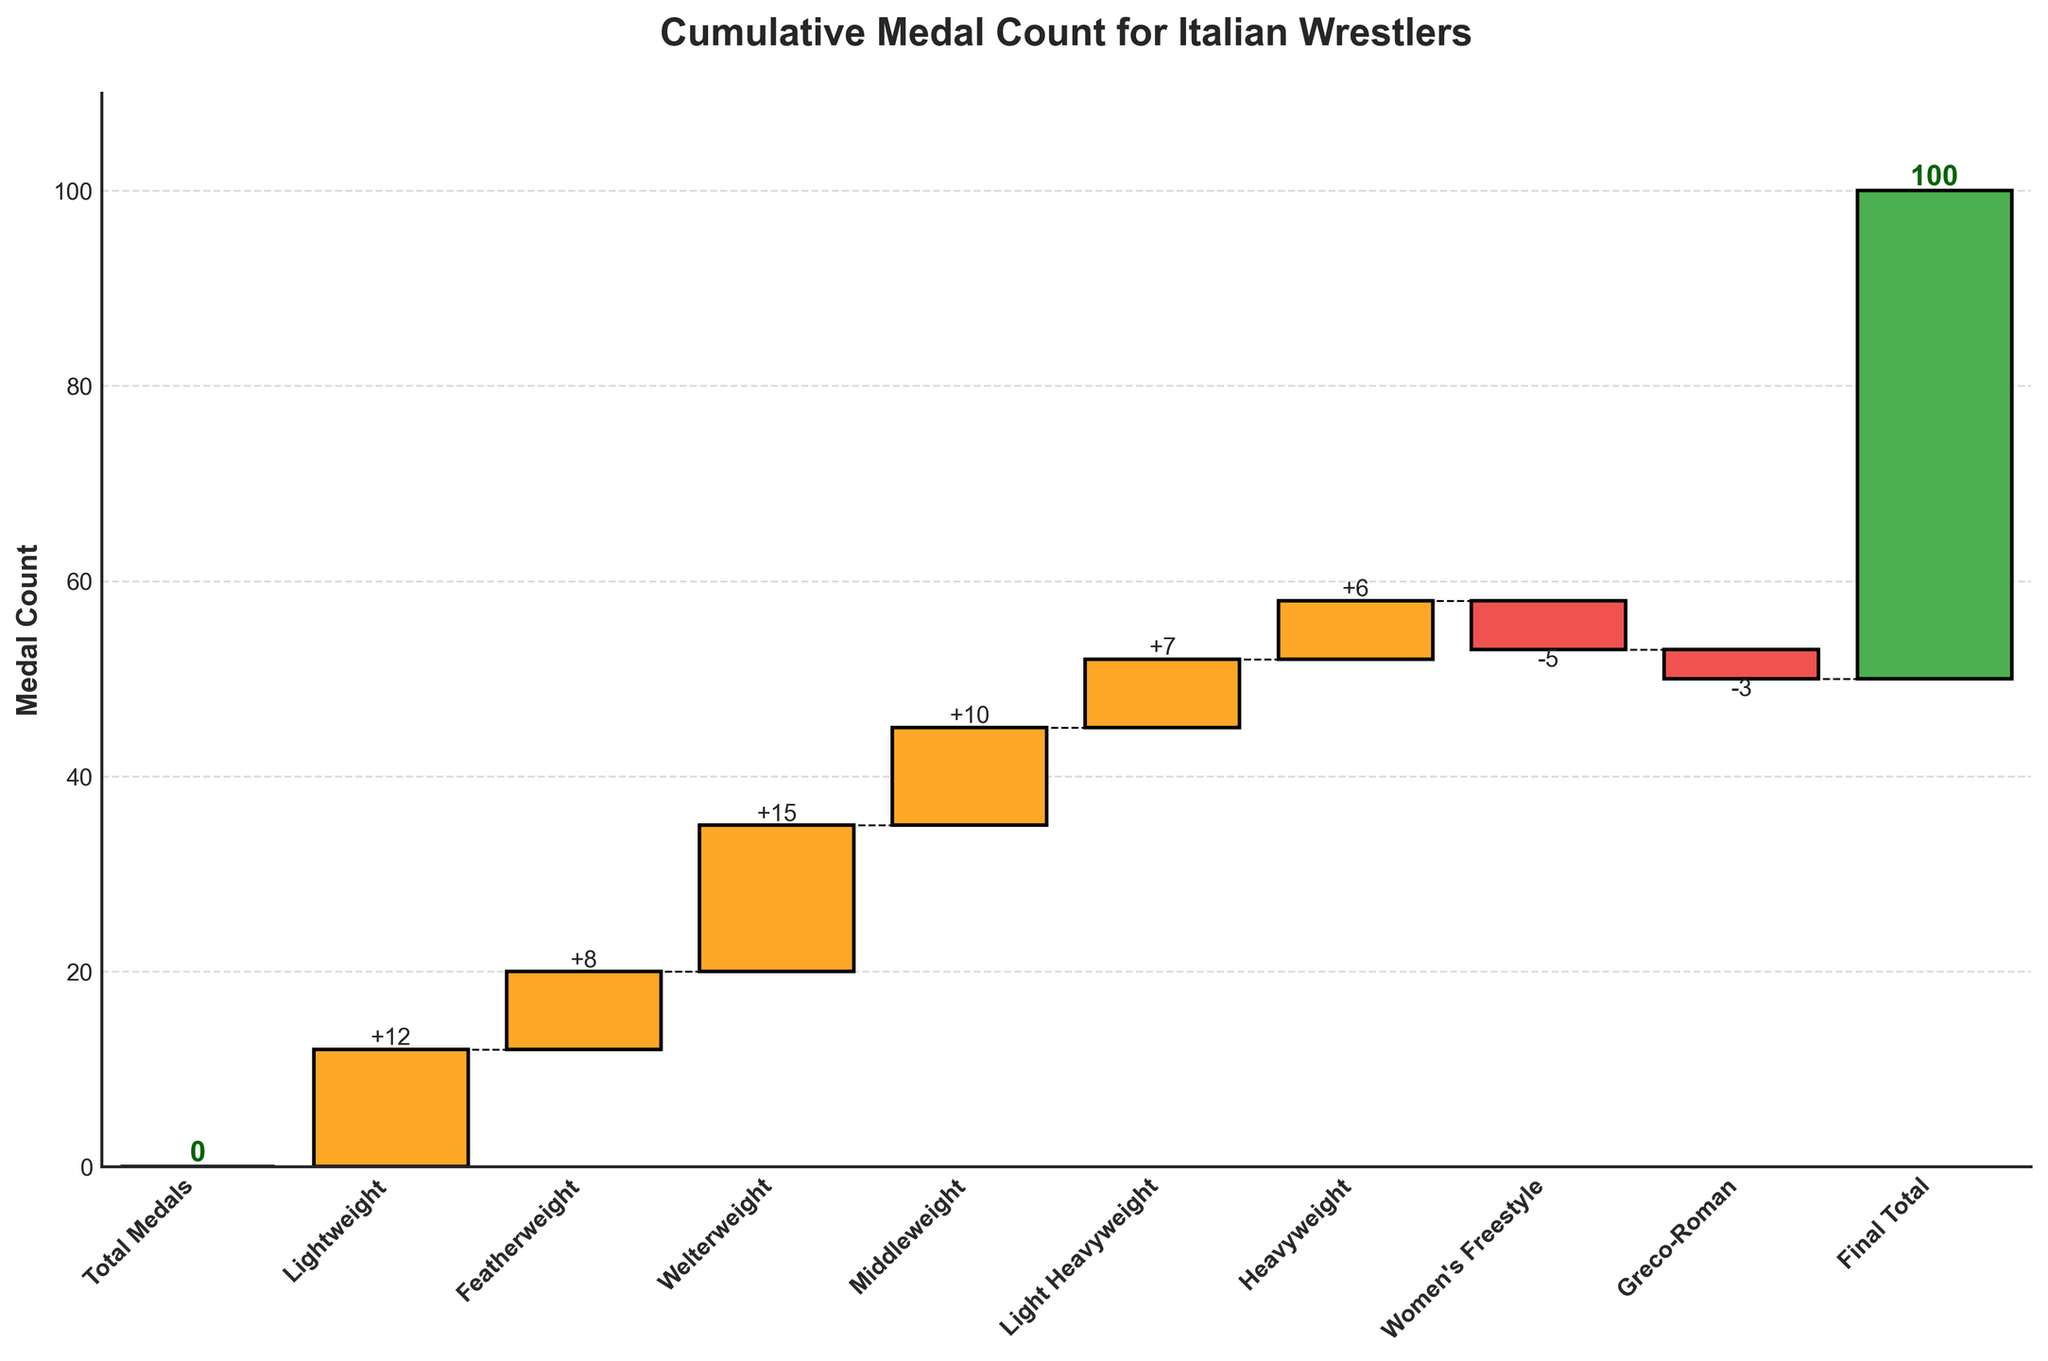What's the title of the chart? The title of the chart is usually displayed prominently at the top. In this case, it reads "Cumulative Medal Count for Italian Wrestlers".
Answer: Cumulative Medal Count for Italian Wrestlers What is the value for the Welterweight category? Locate the Welterweight bar on the x-axis and read the value associated with it. The Welterweight bar has a positive value of 15 medals.
Answer: 15 What is the effect of the Women's Freestyle category on the cumulative medal count? Identify the Women's Freestyle category. The bar is negative, meaning it reduces the cumulative medal count by 5 medals.
Answer: -5 Which weight class has the highest contribution to the total medal count? Compare all positive bars to find the highest one. The Welterweight category has the highest value of 15 medals.
Answer: Welterweight By how much does the Greco-Roman category reduce the cumulative total? Locate the Greco-Roman category bar which is negative and read its value. It reduces the total by 3 medals.
Answer: 3 How many weight classes have a positive contribution to the medal count? Count all bars with positive values. They are Lightweight, Featherweight, Welterweight, Middleweight, Light Heavyweight, and Heavyweight, totaling 6 categories.
Answer: 6 What is the cumulative medal count right before adding the Greco-Roman value? Read the cumulative value just before applying the Greco-Roman reduction. Before the -3 reduction, it is the sum of previous values which equals 53.
Answer: 53 Compare the contributions of Lightweight and Middleweight categories. Which one is higher and by how much? Find the values for both categories (Lightweight: 12, Middleweight: 10), then subtract the smaller value from the larger one. The difference is 12 - 10 = 2.
Answer: Lightweight, by 2 medals Calculate the total contribution of Lightweight, Featherweight, and Welterweight categories combined. Sum the values of these categories (12 + 8 + 15). The total is 12 + 8 + 15 = 35.
Answer: 35 What is the final cumulative total after all additions and subtractions? Observe the final bar labeled "Final Total". The cumulative value represented at the top is 50.
Answer: 50 